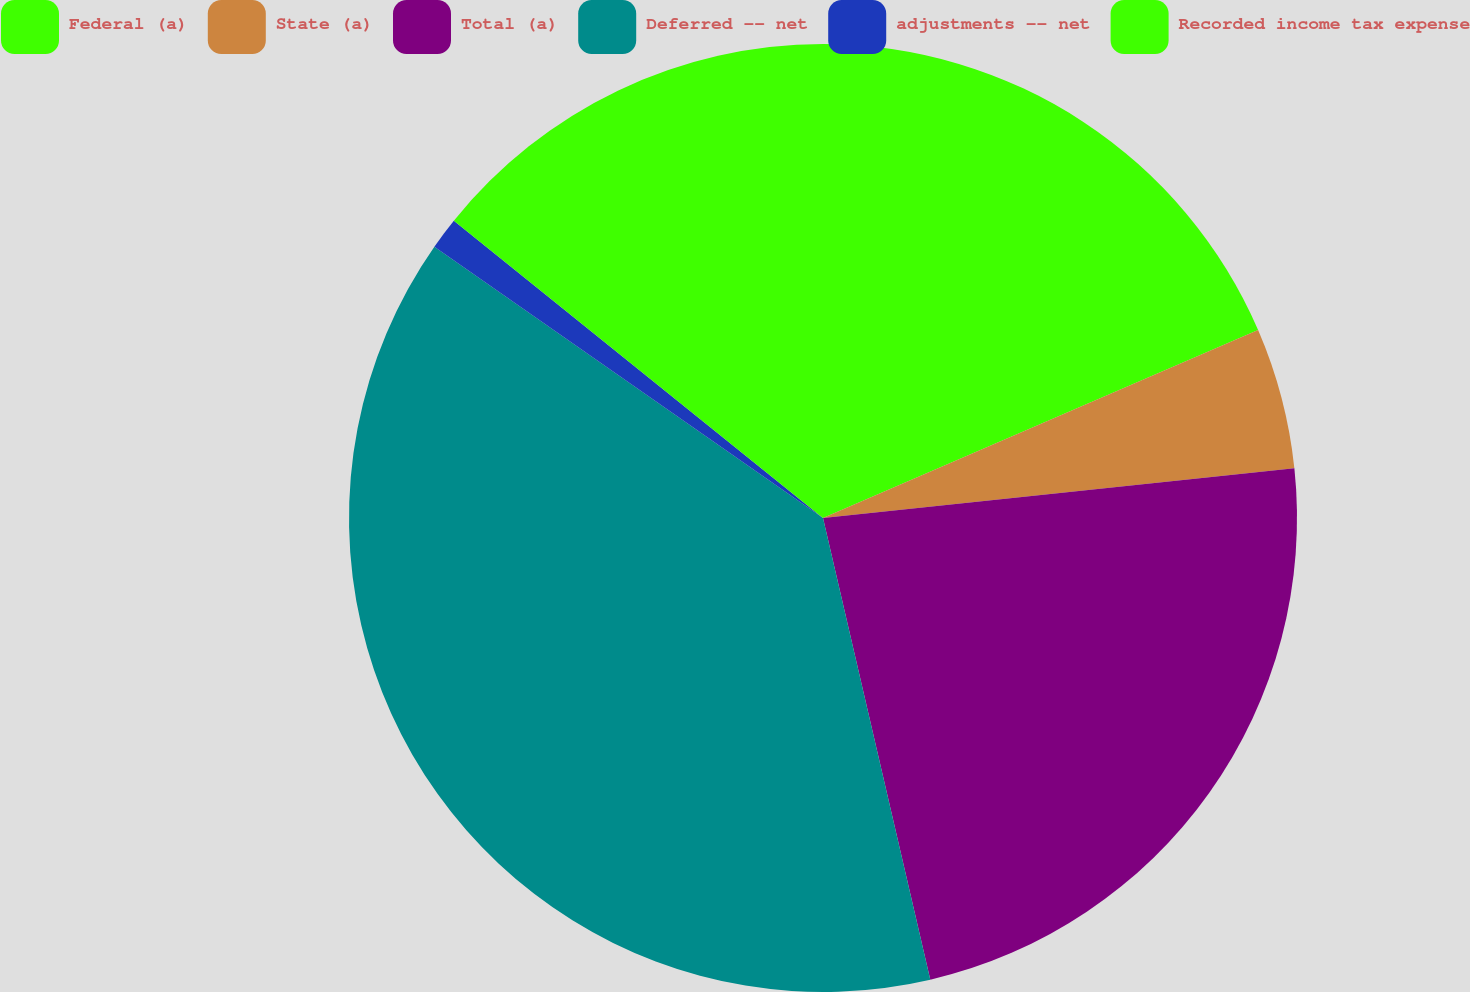<chart> <loc_0><loc_0><loc_500><loc_500><pie_chart><fcel>Federal (a)<fcel>State (a)<fcel>Total (a)<fcel>Deferred -- net<fcel>adjustments -- net<fcel>Recorded income tax expense<nl><fcel>18.51%<fcel>4.82%<fcel>23.04%<fcel>38.34%<fcel>1.09%<fcel>14.21%<nl></chart> 